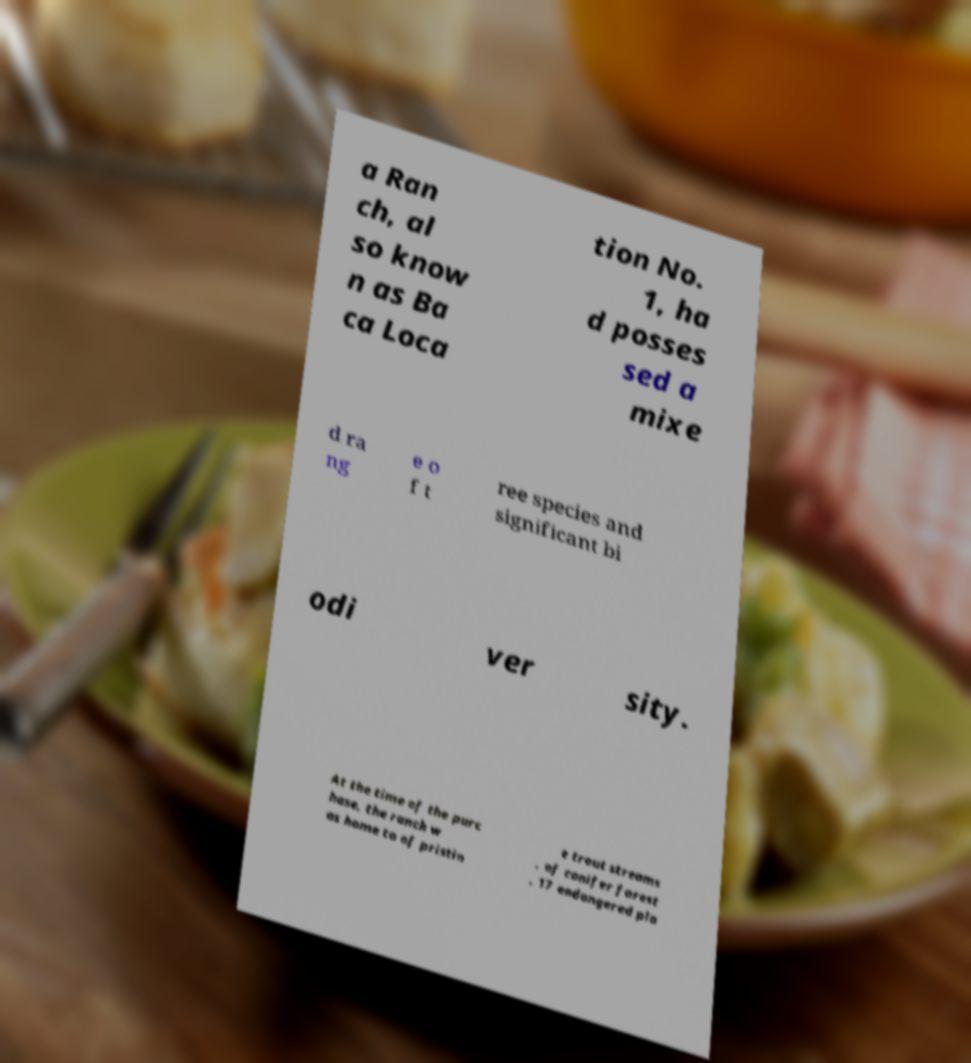There's text embedded in this image that I need extracted. Can you transcribe it verbatim? a Ran ch, al so know n as Ba ca Loca tion No. 1, ha d posses sed a mixe d ra ng e o f t ree species and significant bi odi ver sity. At the time of the purc hase, the ranch w as home to of pristin e trout streams , of conifer forest , 17 endangered pla 